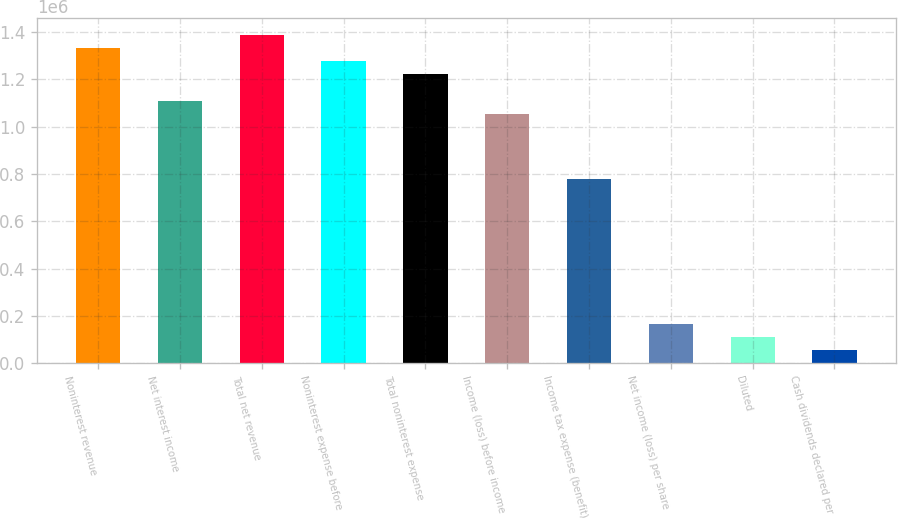<chart> <loc_0><loc_0><loc_500><loc_500><bar_chart><fcel>Noninterest revenue<fcel>Net interest income<fcel>Total net revenue<fcel>Noninterest expense before<fcel>Total noninterest expense<fcel>Income (loss) before income<fcel>Income tax expense (benefit)<fcel>Net income (loss) per share<fcel>Diluted<fcel>Cash dividends declared per<nl><fcel>1.33198e+06<fcel>1.10998e+06<fcel>1.38748e+06<fcel>1.27648e+06<fcel>1.22098e+06<fcel>1.05448e+06<fcel>776987<fcel>166497<fcel>110998<fcel>55499.2<nl></chart> 